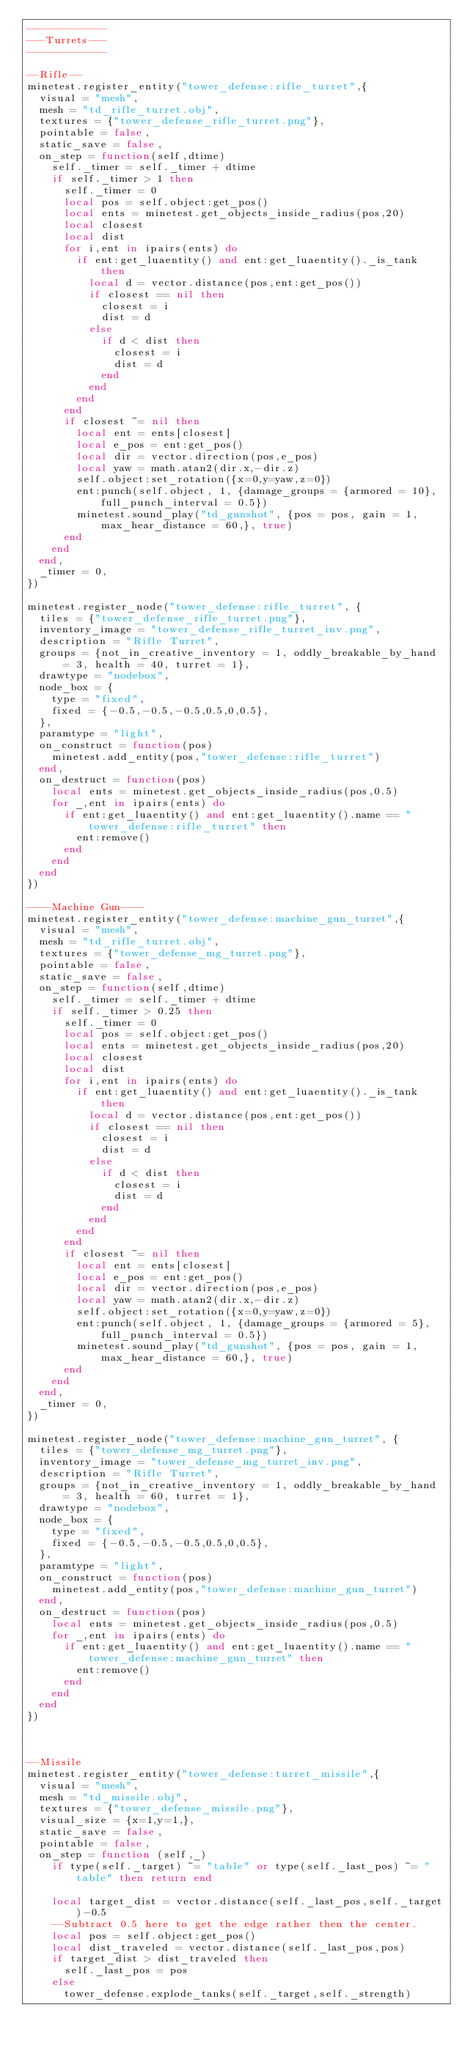Convert code to text. <code><loc_0><loc_0><loc_500><loc_500><_Lua_>-------------
---Turrets---
-------------

--Rifle--
minetest.register_entity("tower_defense:rifle_turret",{
	visual = "mesh",
	mesh = "td_rifle_turret.obj",
	textures = {"tower_defense_rifle_turret.png"},
	pointable = false,
	static_save = false,
	on_step = function(self,dtime)
		self._timer = self._timer + dtime
		if self._timer > 1 then
			self._timer = 0
			local pos = self.object:get_pos()
			local ents = minetest.get_objects_inside_radius(pos,20)
			local closest
			local dist
			for i,ent in ipairs(ents) do
				if ent:get_luaentity() and ent:get_luaentity()._is_tank then
					local d = vector.distance(pos,ent:get_pos())
					if closest == nil then
						closest = i
						dist = d
					else
						if d < dist then
							closest = i
							dist = d
						end
					end
				end
			end
			if closest ~= nil then
				local ent = ents[closest]
				local e_pos = ent:get_pos()
				local dir = vector.direction(pos,e_pos)
				local yaw = math.atan2(dir.x,-dir.z)
				self.object:set_rotation({x=0,y=yaw,z=0})
				ent:punch(self.object, 1, {damage_groups = {armored = 10},full_punch_interval = 0.5})
				minetest.sound_play("td_gunshot", {pos = pos, gain = 1, max_hear_distance = 60,}, true)
			end
		end
	end,
	_timer = 0,
})

minetest.register_node("tower_defense:rifle_turret", {
	tiles = {"tower_defense_rifle_turret.png"},
	inventory_image = "tower_defense_rifle_turret_inv.png",
	description = "Rifle Turret",
	groups = {not_in_creative_inventory = 1, oddly_breakable_by_hand = 3, health = 40, turret = 1},
	drawtype = "nodebox",
	node_box = {
		type = "fixed",
		fixed = {-0.5,-0.5,-0.5,0.5,0,0.5},
	},
	paramtype = "light",
	on_construct = function(pos)
		minetest.add_entity(pos,"tower_defense:rifle_turret")
	end,
	on_destruct = function(pos)
		local ents = minetest.get_objects_inside_radius(pos,0.5)
		for _,ent in ipairs(ents) do
			if ent:get_luaentity() and ent:get_luaentity().name == "tower_defense:rifle_turret" then
				ent:remove()
			end
		end
	end
})

----Machine Gun----
minetest.register_entity("tower_defense:machine_gun_turret",{
	visual = "mesh",
	mesh = "td_rifle_turret.obj",
	textures = {"tower_defense_mg_turret.png"},
	pointable = false,
	static_save = false,
	on_step = function(self,dtime)
		self._timer = self._timer + dtime
		if self._timer > 0.25 then
			self._timer = 0
			local pos = self.object:get_pos()
			local ents = minetest.get_objects_inside_radius(pos,20)
			local closest
			local dist
			for i,ent in ipairs(ents) do
				if ent:get_luaentity() and ent:get_luaentity()._is_tank then
					local d = vector.distance(pos,ent:get_pos())
					if closest == nil then
						closest = i
						dist = d
					else
						if d < dist then
							closest = i
							dist = d
						end
					end
				end
			end
			if closest ~= nil then
				local ent = ents[closest]
				local e_pos = ent:get_pos()
				local dir = vector.direction(pos,e_pos)
				local yaw = math.atan2(dir.x,-dir.z)
				self.object:set_rotation({x=0,y=yaw,z=0})
				ent:punch(self.object, 1, {damage_groups = {armored = 5},full_punch_interval = 0.5})
				minetest.sound_play("td_gunshot", {pos = pos, gain = 1, max_hear_distance = 60,}, true)
			end
		end
	end,
	_timer = 0,
})

minetest.register_node("tower_defense:machine_gun_turret", {
	tiles = {"tower_defense_mg_turret.png"},
	inventory_image = "tower_defense_mg_turret_inv.png",
	description = "Rifle Turret",
	groups = {not_in_creative_inventory = 1, oddly_breakable_by_hand = 3, health = 60, turret = 1},
	drawtype = "nodebox",
	node_box = {
		type = "fixed",
		fixed = {-0.5,-0.5,-0.5,0.5,0,0.5},
	},
	paramtype = "light",
	on_construct = function(pos)
		minetest.add_entity(pos,"tower_defense:machine_gun_turret")
	end,
	on_destruct = function(pos)
		local ents = minetest.get_objects_inside_radius(pos,0.5)
		for _,ent in ipairs(ents) do
			if ent:get_luaentity() and ent:get_luaentity().name == "tower_defense:machine_gun_turret" then
				ent:remove()
			end
		end
	end
})



--Missile
minetest.register_entity("tower_defense:turret_missile",{
	visual = "mesh",
	mesh = "td_missile.obj",
	textures = {"tower_defense_missile.png"},
	visual_size = {x=1,y=1,},
	static_save = false,
	pointable = false,
	on_step = function (self,_)
		if type(self._target) ~= "table" or type(self._last_pos) ~= "table" then return end

		local target_dist = vector.distance(self._last_pos,self._target)-0.5
		--Subtract 0.5 here to get the edge rather then the center.
		local pos = self.object:get_pos()
		local dist_traveled = vector.distance(self._last_pos,pos)
		if target_dist > dist_traveled then
			self._last_pos = pos
		else
			tower_defense.explode_tanks(self._target,self._strength)</code> 